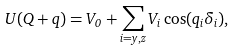Convert formula to latex. <formula><loc_0><loc_0><loc_500><loc_500>U ( { Q + q } ) = V _ { 0 } + \sum _ { i = y , z } V _ { i } \cos ( q _ { i } \delta _ { i } ) ,</formula> 